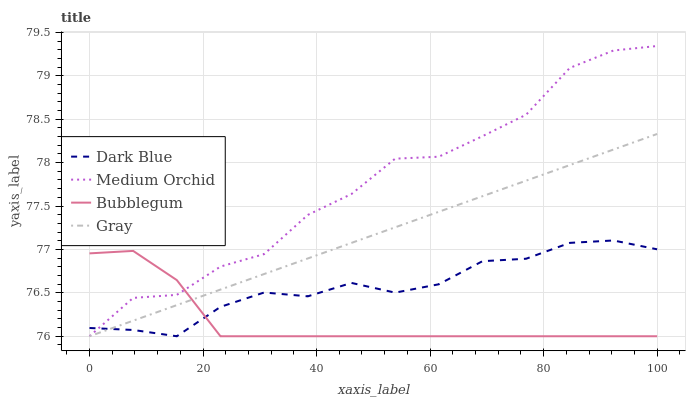Does Bubblegum have the minimum area under the curve?
Answer yes or no. Yes. Does Medium Orchid have the maximum area under the curve?
Answer yes or no. Yes. Does Medium Orchid have the minimum area under the curve?
Answer yes or no. No. Does Bubblegum have the maximum area under the curve?
Answer yes or no. No. Is Gray the smoothest?
Answer yes or no. Yes. Is Medium Orchid the roughest?
Answer yes or no. Yes. Is Bubblegum the smoothest?
Answer yes or no. No. Is Bubblegum the roughest?
Answer yes or no. No. Does Dark Blue have the lowest value?
Answer yes or no. Yes. Does Medium Orchid have the highest value?
Answer yes or no. Yes. Does Bubblegum have the highest value?
Answer yes or no. No. Does Gray intersect Bubblegum?
Answer yes or no. Yes. Is Gray less than Bubblegum?
Answer yes or no. No. Is Gray greater than Bubblegum?
Answer yes or no. No. 